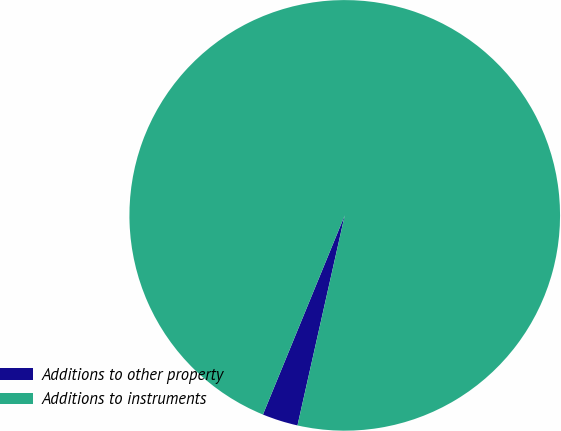Convert chart to OTSL. <chart><loc_0><loc_0><loc_500><loc_500><pie_chart><fcel>Additions to other property<fcel>Additions to instruments<nl><fcel>2.68%<fcel>97.32%<nl></chart> 